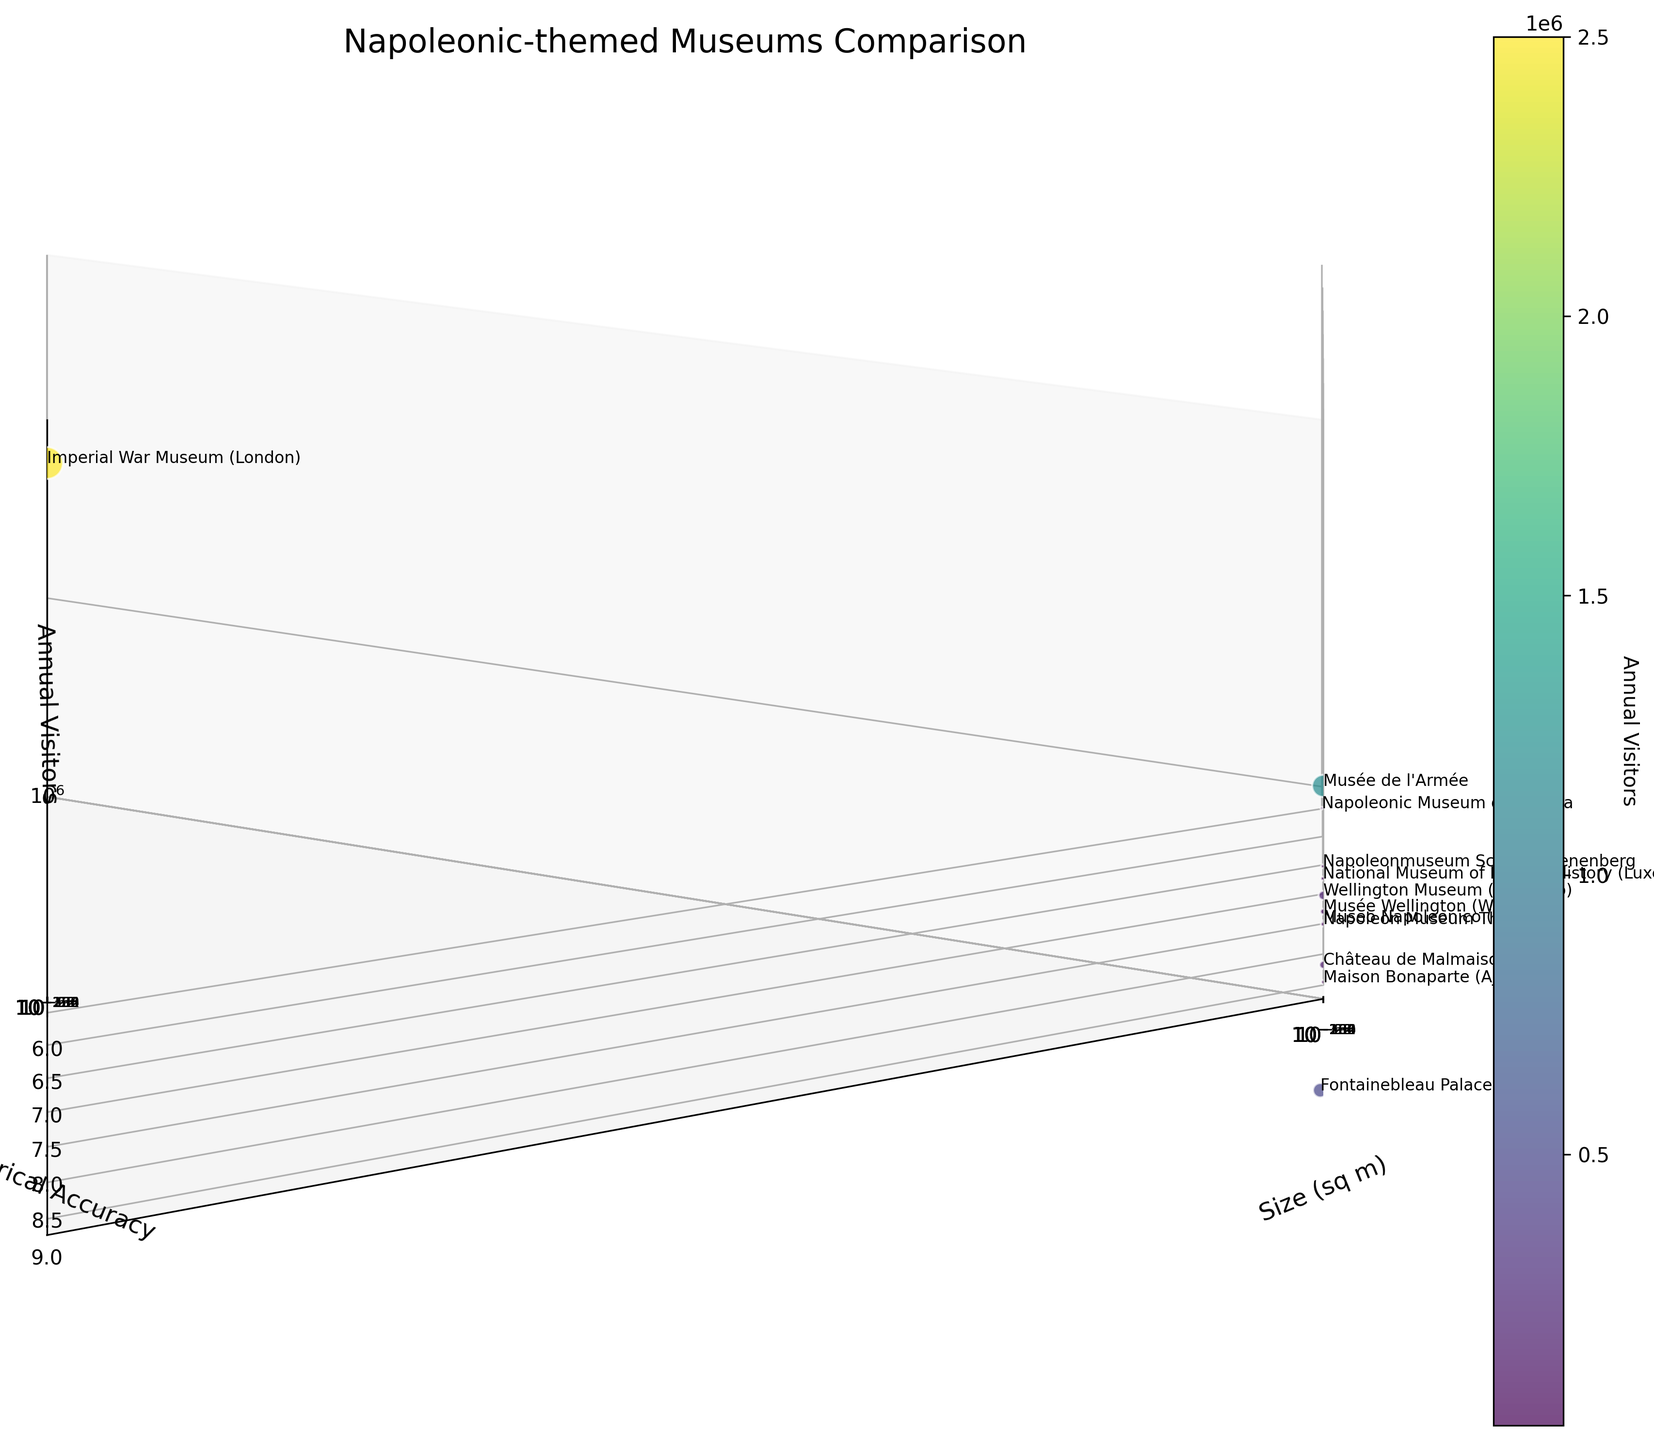Which museum has the highest number of annual visitors? By examining the "Annual Visitors" axis and data points, we see that the Imperial War Museum (London) has the highest position on this axis.
Answer: Imperial War Museum (London) On the logarithmic scale, which museum has the smallest size? By locating the smallest value on the "Size (sq m)" axis, we notice that the Napoleonic Museum of Havana lies closest to the minimum value.
Answer: Napoleonic Museum of Havana Which museum scores highest in terms of historical accuracy and also has a significant number of visitors? Among museums with a historical accuracy of 9, we compare their "Annual Visitors" values. Fontainebleau Palace is the one with considerable annual visitors.
Answer: Fontainebleau Palace What is the size difference between the Musée de l'Armée and Maison Bonaparte? Comparing the "Size (sq m)" values of Musée de l'Armée (13000) and Maison Bonaparte (1200), we calculate the difference as 13000 - 1200 = 11800 sq m.
Answer: 11800 sq m Which museum has the lowest historical accuracy but relatively high annual visitors? Observing the "Historical Accuracy" axis, the Napoleonic Museum of Havana has the lowest score of 6, and its "Annual Visitors" value is 15000.
Answer: Napoleonic Museum of Havana What is the average size of all museums combined? Summing the "Size (sq m)" of all museums: (13000 + 2500 + 5000 + 800 + 1200 + 3000 + 1800 + 45000 + 600 + 1000 + 32000 + 2500), which equals 106400 sq m. Dividing by the number of museums (12), the average size is 106400 / 12 ≈ 8867 sq m.
Answer: 8867 sq m Which museum has the same historical accuracy as Wellington Museum (Waterloo) but different visitor numbers? Both the Musée Wellington (Waterloo) and Museo Napoleonico (Rome) have a historical accuracy of 8, but they differ in annual visitors (Museo Napoleonico: 25000, Musée Wellington: 80000).
Answer: Museo Napoleonico (Rome) 